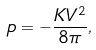Convert formula to latex. <formula><loc_0><loc_0><loc_500><loc_500>p = - \frac { K V ^ { 2 } } { 8 \pi } ,</formula> 